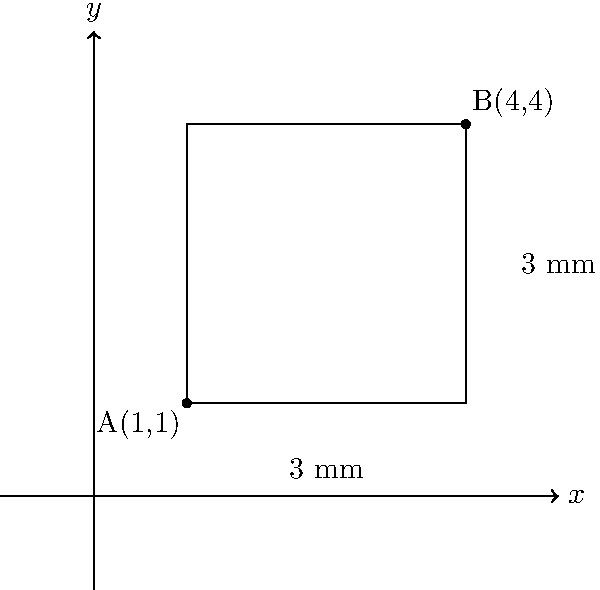A traditional lock's keyway is represented in a Cartesian coordinate system. Point A(1,1) marks the bottom-left corner, and point B(4,4) marks the top-right corner of the keyway. What are the dimensions (width and height) of this keyway in millimeters? To determine the dimensions of the keyway, we need to calculate the distance between the x-coordinates and y-coordinates of points A and B.

Step 1: Calculate the width (along the x-axis)
Width = x-coordinate of B - x-coordinate of A
Width = 4 - 1 = 3 mm

Step 2: Calculate the height (along the y-axis)
Height = y-coordinate of B - y-coordinate of A
Height = 4 - 1 = 3 mm

Step 3: Express the dimensions as width × height
Dimensions = 3 mm × 3 mm

This method of using a coordinate system to measure lock components is particularly useful for precision work, which is essential when catering to elderly clients who may prefer traditional lock systems and require accurate, reliable service.
Answer: 3 mm × 3 mm 